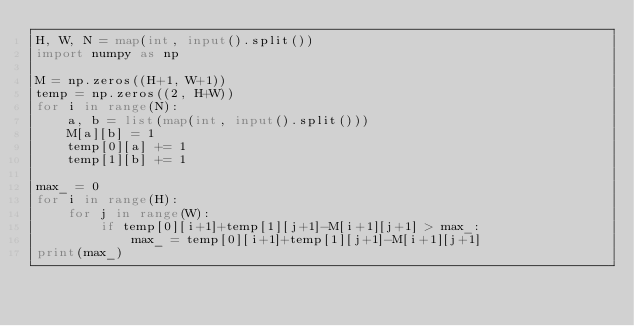Convert code to text. <code><loc_0><loc_0><loc_500><loc_500><_Python_>H, W, N = map(int, input().split())
import numpy as np

M = np.zeros((H+1, W+1))
temp = np.zeros((2, H+W))
for i in range(N):
    a, b = list(map(int, input().split()))
    M[a][b] = 1
    temp[0][a] += 1
    temp[1][b] += 1

max_ = 0
for i in range(H):
    for j in range(W):
        if temp[0][i+1]+temp[1][j+1]-M[i+1][j+1] > max_:
            max_ = temp[0][i+1]+temp[1][j+1]-M[i+1][j+1]
print(max_)</code> 